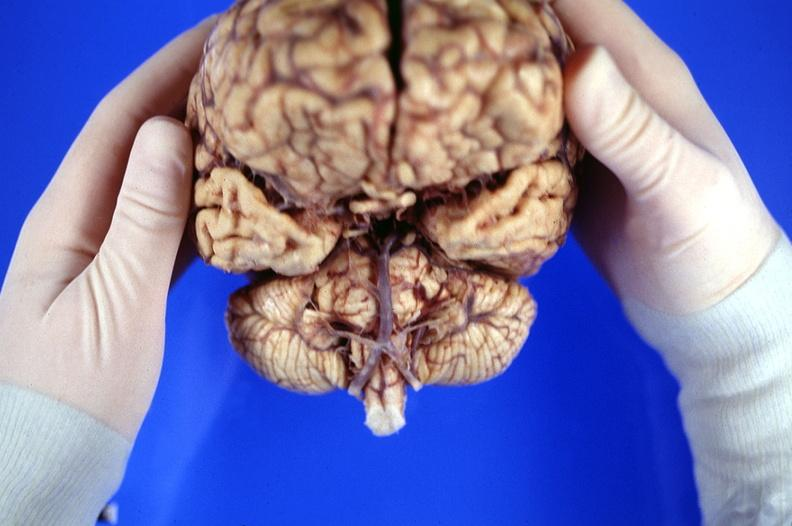does heel ulcer show brain, frontal lobe atrophy, pick 's disease?
Answer the question using a single word or phrase. No 